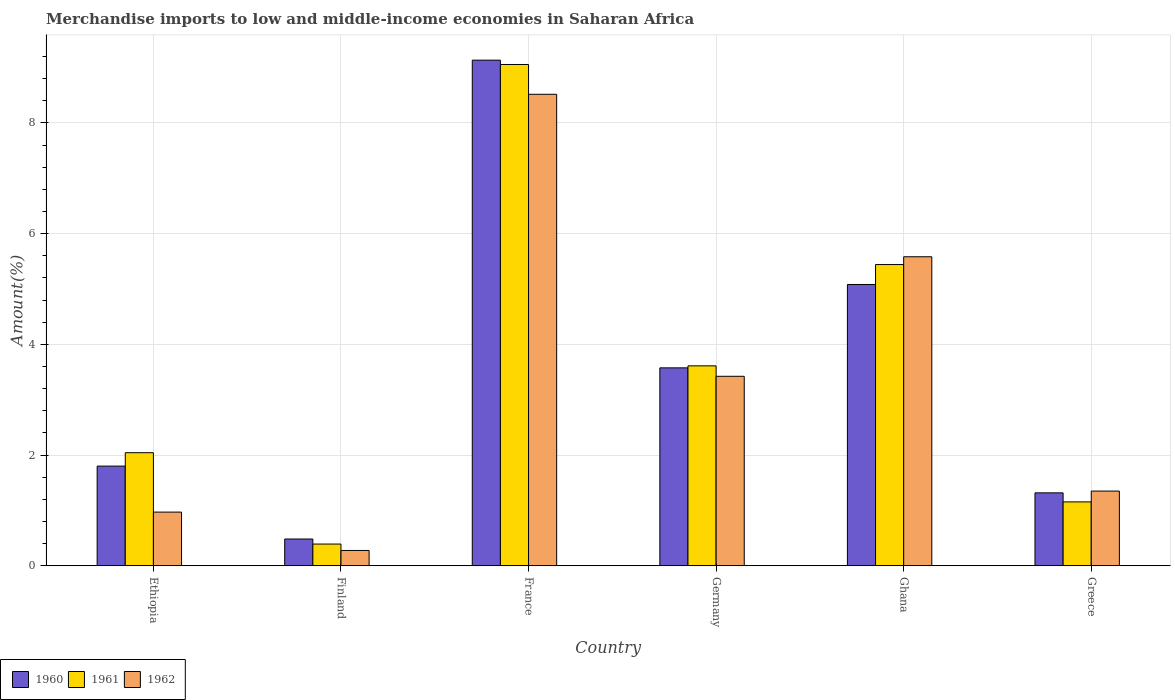How many groups of bars are there?
Make the answer very short. 6. How many bars are there on the 4th tick from the right?
Ensure brevity in your answer.  3. What is the label of the 6th group of bars from the left?
Your answer should be very brief. Greece. In how many cases, is the number of bars for a given country not equal to the number of legend labels?
Offer a very short reply. 0. What is the percentage of amount earned from merchandise imports in 1961 in Ghana?
Ensure brevity in your answer.  5.44. Across all countries, what is the maximum percentage of amount earned from merchandise imports in 1960?
Make the answer very short. 9.13. Across all countries, what is the minimum percentage of amount earned from merchandise imports in 1962?
Make the answer very short. 0.28. In which country was the percentage of amount earned from merchandise imports in 1962 maximum?
Give a very brief answer. France. In which country was the percentage of amount earned from merchandise imports in 1960 minimum?
Offer a terse response. Finland. What is the total percentage of amount earned from merchandise imports in 1962 in the graph?
Offer a terse response. 20.12. What is the difference between the percentage of amount earned from merchandise imports in 1962 in Finland and that in France?
Ensure brevity in your answer.  -8.24. What is the difference between the percentage of amount earned from merchandise imports in 1962 in Ethiopia and the percentage of amount earned from merchandise imports in 1961 in Germany?
Provide a short and direct response. -2.64. What is the average percentage of amount earned from merchandise imports in 1962 per country?
Offer a very short reply. 3.35. What is the difference between the percentage of amount earned from merchandise imports of/in 1961 and percentage of amount earned from merchandise imports of/in 1962 in Ethiopia?
Give a very brief answer. 1.07. In how many countries, is the percentage of amount earned from merchandise imports in 1962 greater than 4 %?
Give a very brief answer. 2. What is the ratio of the percentage of amount earned from merchandise imports in 1962 in Finland to that in Germany?
Your answer should be very brief. 0.08. What is the difference between the highest and the second highest percentage of amount earned from merchandise imports in 1960?
Your answer should be compact. 5.56. What is the difference between the highest and the lowest percentage of amount earned from merchandise imports in 1960?
Keep it short and to the point. 8.65. In how many countries, is the percentage of amount earned from merchandise imports in 1960 greater than the average percentage of amount earned from merchandise imports in 1960 taken over all countries?
Provide a succinct answer. 3. Are all the bars in the graph horizontal?
Your response must be concise. No. Where does the legend appear in the graph?
Your answer should be compact. Bottom left. What is the title of the graph?
Ensure brevity in your answer.  Merchandise imports to low and middle-income economies in Saharan Africa. Does "1988" appear as one of the legend labels in the graph?
Your response must be concise. No. What is the label or title of the X-axis?
Provide a succinct answer. Country. What is the label or title of the Y-axis?
Your answer should be very brief. Amount(%). What is the Amount(%) in 1960 in Ethiopia?
Make the answer very short. 1.8. What is the Amount(%) of 1961 in Ethiopia?
Your answer should be compact. 2.04. What is the Amount(%) of 1962 in Ethiopia?
Your response must be concise. 0.97. What is the Amount(%) of 1960 in Finland?
Your answer should be very brief. 0.48. What is the Amount(%) of 1961 in Finland?
Your answer should be compact. 0.39. What is the Amount(%) in 1962 in Finland?
Offer a terse response. 0.28. What is the Amount(%) of 1960 in France?
Provide a short and direct response. 9.13. What is the Amount(%) of 1961 in France?
Your answer should be very brief. 9.06. What is the Amount(%) in 1962 in France?
Provide a short and direct response. 8.52. What is the Amount(%) in 1960 in Germany?
Keep it short and to the point. 3.58. What is the Amount(%) of 1961 in Germany?
Offer a very short reply. 3.61. What is the Amount(%) in 1962 in Germany?
Give a very brief answer. 3.42. What is the Amount(%) in 1960 in Ghana?
Provide a succinct answer. 5.08. What is the Amount(%) in 1961 in Ghana?
Ensure brevity in your answer.  5.44. What is the Amount(%) in 1962 in Ghana?
Ensure brevity in your answer.  5.58. What is the Amount(%) in 1960 in Greece?
Your response must be concise. 1.32. What is the Amount(%) of 1961 in Greece?
Provide a succinct answer. 1.15. What is the Amount(%) of 1962 in Greece?
Give a very brief answer. 1.35. Across all countries, what is the maximum Amount(%) of 1960?
Provide a short and direct response. 9.13. Across all countries, what is the maximum Amount(%) in 1961?
Provide a short and direct response. 9.06. Across all countries, what is the maximum Amount(%) of 1962?
Your answer should be compact. 8.52. Across all countries, what is the minimum Amount(%) in 1960?
Your answer should be very brief. 0.48. Across all countries, what is the minimum Amount(%) of 1961?
Your answer should be compact. 0.39. Across all countries, what is the minimum Amount(%) in 1962?
Ensure brevity in your answer.  0.28. What is the total Amount(%) in 1960 in the graph?
Provide a succinct answer. 21.39. What is the total Amount(%) in 1961 in the graph?
Provide a short and direct response. 21.7. What is the total Amount(%) of 1962 in the graph?
Your response must be concise. 20.12. What is the difference between the Amount(%) in 1960 in Ethiopia and that in Finland?
Offer a terse response. 1.32. What is the difference between the Amount(%) in 1961 in Ethiopia and that in Finland?
Offer a very short reply. 1.65. What is the difference between the Amount(%) in 1962 in Ethiopia and that in Finland?
Your answer should be very brief. 0.69. What is the difference between the Amount(%) of 1960 in Ethiopia and that in France?
Ensure brevity in your answer.  -7.33. What is the difference between the Amount(%) of 1961 in Ethiopia and that in France?
Make the answer very short. -7.01. What is the difference between the Amount(%) in 1962 in Ethiopia and that in France?
Give a very brief answer. -7.55. What is the difference between the Amount(%) of 1960 in Ethiopia and that in Germany?
Your answer should be very brief. -1.77. What is the difference between the Amount(%) in 1961 in Ethiopia and that in Germany?
Give a very brief answer. -1.57. What is the difference between the Amount(%) in 1962 in Ethiopia and that in Germany?
Your response must be concise. -2.45. What is the difference between the Amount(%) of 1960 in Ethiopia and that in Ghana?
Give a very brief answer. -3.28. What is the difference between the Amount(%) of 1961 in Ethiopia and that in Ghana?
Your response must be concise. -3.4. What is the difference between the Amount(%) of 1962 in Ethiopia and that in Ghana?
Provide a succinct answer. -4.61. What is the difference between the Amount(%) in 1960 in Ethiopia and that in Greece?
Ensure brevity in your answer.  0.48. What is the difference between the Amount(%) of 1962 in Ethiopia and that in Greece?
Provide a succinct answer. -0.38. What is the difference between the Amount(%) of 1960 in Finland and that in France?
Your answer should be very brief. -8.65. What is the difference between the Amount(%) in 1961 in Finland and that in France?
Provide a succinct answer. -8.66. What is the difference between the Amount(%) of 1962 in Finland and that in France?
Keep it short and to the point. -8.24. What is the difference between the Amount(%) of 1960 in Finland and that in Germany?
Your response must be concise. -3.09. What is the difference between the Amount(%) of 1961 in Finland and that in Germany?
Provide a short and direct response. -3.22. What is the difference between the Amount(%) in 1962 in Finland and that in Germany?
Offer a terse response. -3.15. What is the difference between the Amount(%) of 1960 in Finland and that in Ghana?
Ensure brevity in your answer.  -4.6. What is the difference between the Amount(%) of 1961 in Finland and that in Ghana?
Make the answer very short. -5.05. What is the difference between the Amount(%) in 1962 in Finland and that in Ghana?
Ensure brevity in your answer.  -5.31. What is the difference between the Amount(%) in 1960 in Finland and that in Greece?
Offer a terse response. -0.83. What is the difference between the Amount(%) in 1961 in Finland and that in Greece?
Provide a succinct answer. -0.76. What is the difference between the Amount(%) in 1962 in Finland and that in Greece?
Keep it short and to the point. -1.07. What is the difference between the Amount(%) in 1960 in France and that in Germany?
Provide a succinct answer. 5.56. What is the difference between the Amount(%) of 1961 in France and that in Germany?
Your answer should be very brief. 5.44. What is the difference between the Amount(%) in 1962 in France and that in Germany?
Your answer should be very brief. 5.09. What is the difference between the Amount(%) of 1960 in France and that in Ghana?
Offer a very short reply. 4.05. What is the difference between the Amount(%) in 1961 in France and that in Ghana?
Make the answer very short. 3.61. What is the difference between the Amount(%) of 1962 in France and that in Ghana?
Make the answer very short. 2.93. What is the difference between the Amount(%) of 1960 in France and that in Greece?
Make the answer very short. 7.82. What is the difference between the Amount(%) in 1961 in France and that in Greece?
Provide a short and direct response. 7.9. What is the difference between the Amount(%) in 1962 in France and that in Greece?
Your answer should be very brief. 7.17. What is the difference between the Amount(%) in 1960 in Germany and that in Ghana?
Ensure brevity in your answer.  -1.51. What is the difference between the Amount(%) of 1961 in Germany and that in Ghana?
Your response must be concise. -1.83. What is the difference between the Amount(%) of 1962 in Germany and that in Ghana?
Provide a short and direct response. -2.16. What is the difference between the Amount(%) of 1960 in Germany and that in Greece?
Your answer should be very brief. 2.26. What is the difference between the Amount(%) of 1961 in Germany and that in Greece?
Your response must be concise. 2.46. What is the difference between the Amount(%) of 1962 in Germany and that in Greece?
Your answer should be very brief. 2.07. What is the difference between the Amount(%) in 1960 in Ghana and that in Greece?
Your response must be concise. 3.76. What is the difference between the Amount(%) in 1961 in Ghana and that in Greece?
Give a very brief answer. 4.29. What is the difference between the Amount(%) in 1962 in Ghana and that in Greece?
Provide a short and direct response. 4.23. What is the difference between the Amount(%) of 1960 in Ethiopia and the Amount(%) of 1961 in Finland?
Provide a short and direct response. 1.41. What is the difference between the Amount(%) in 1960 in Ethiopia and the Amount(%) in 1962 in Finland?
Your answer should be compact. 1.52. What is the difference between the Amount(%) of 1961 in Ethiopia and the Amount(%) of 1962 in Finland?
Ensure brevity in your answer.  1.77. What is the difference between the Amount(%) of 1960 in Ethiopia and the Amount(%) of 1961 in France?
Your answer should be very brief. -7.25. What is the difference between the Amount(%) in 1960 in Ethiopia and the Amount(%) in 1962 in France?
Ensure brevity in your answer.  -6.72. What is the difference between the Amount(%) of 1961 in Ethiopia and the Amount(%) of 1962 in France?
Give a very brief answer. -6.47. What is the difference between the Amount(%) of 1960 in Ethiopia and the Amount(%) of 1961 in Germany?
Your response must be concise. -1.81. What is the difference between the Amount(%) in 1960 in Ethiopia and the Amount(%) in 1962 in Germany?
Make the answer very short. -1.62. What is the difference between the Amount(%) of 1961 in Ethiopia and the Amount(%) of 1962 in Germany?
Offer a terse response. -1.38. What is the difference between the Amount(%) in 1960 in Ethiopia and the Amount(%) in 1961 in Ghana?
Give a very brief answer. -3.64. What is the difference between the Amount(%) in 1960 in Ethiopia and the Amount(%) in 1962 in Ghana?
Offer a very short reply. -3.78. What is the difference between the Amount(%) in 1961 in Ethiopia and the Amount(%) in 1962 in Ghana?
Your answer should be compact. -3.54. What is the difference between the Amount(%) of 1960 in Ethiopia and the Amount(%) of 1961 in Greece?
Offer a very short reply. 0.65. What is the difference between the Amount(%) in 1960 in Ethiopia and the Amount(%) in 1962 in Greece?
Keep it short and to the point. 0.45. What is the difference between the Amount(%) in 1961 in Ethiopia and the Amount(%) in 1962 in Greece?
Your answer should be very brief. 0.69. What is the difference between the Amount(%) in 1960 in Finland and the Amount(%) in 1961 in France?
Your answer should be very brief. -8.57. What is the difference between the Amount(%) in 1960 in Finland and the Amount(%) in 1962 in France?
Keep it short and to the point. -8.03. What is the difference between the Amount(%) in 1961 in Finland and the Amount(%) in 1962 in France?
Make the answer very short. -8.12. What is the difference between the Amount(%) of 1960 in Finland and the Amount(%) of 1961 in Germany?
Your answer should be very brief. -3.13. What is the difference between the Amount(%) of 1960 in Finland and the Amount(%) of 1962 in Germany?
Give a very brief answer. -2.94. What is the difference between the Amount(%) of 1961 in Finland and the Amount(%) of 1962 in Germany?
Make the answer very short. -3.03. What is the difference between the Amount(%) in 1960 in Finland and the Amount(%) in 1961 in Ghana?
Make the answer very short. -4.96. What is the difference between the Amount(%) of 1960 in Finland and the Amount(%) of 1962 in Ghana?
Your answer should be compact. -5.1. What is the difference between the Amount(%) of 1961 in Finland and the Amount(%) of 1962 in Ghana?
Offer a terse response. -5.19. What is the difference between the Amount(%) of 1960 in Finland and the Amount(%) of 1961 in Greece?
Ensure brevity in your answer.  -0.67. What is the difference between the Amount(%) in 1960 in Finland and the Amount(%) in 1962 in Greece?
Make the answer very short. -0.87. What is the difference between the Amount(%) in 1961 in Finland and the Amount(%) in 1962 in Greece?
Your response must be concise. -0.96. What is the difference between the Amount(%) in 1960 in France and the Amount(%) in 1961 in Germany?
Make the answer very short. 5.52. What is the difference between the Amount(%) in 1960 in France and the Amount(%) in 1962 in Germany?
Provide a succinct answer. 5.71. What is the difference between the Amount(%) in 1961 in France and the Amount(%) in 1962 in Germany?
Give a very brief answer. 5.63. What is the difference between the Amount(%) of 1960 in France and the Amount(%) of 1961 in Ghana?
Make the answer very short. 3.69. What is the difference between the Amount(%) of 1960 in France and the Amount(%) of 1962 in Ghana?
Keep it short and to the point. 3.55. What is the difference between the Amount(%) of 1961 in France and the Amount(%) of 1962 in Ghana?
Give a very brief answer. 3.47. What is the difference between the Amount(%) in 1960 in France and the Amount(%) in 1961 in Greece?
Make the answer very short. 7.98. What is the difference between the Amount(%) in 1960 in France and the Amount(%) in 1962 in Greece?
Provide a succinct answer. 7.78. What is the difference between the Amount(%) of 1961 in France and the Amount(%) of 1962 in Greece?
Keep it short and to the point. 7.71. What is the difference between the Amount(%) in 1960 in Germany and the Amount(%) in 1961 in Ghana?
Offer a terse response. -1.87. What is the difference between the Amount(%) of 1960 in Germany and the Amount(%) of 1962 in Ghana?
Your answer should be very brief. -2.01. What is the difference between the Amount(%) of 1961 in Germany and the Amount(%) of 1962 in Ghana?
Your answer should be very brief. -1.97. What is the difference between the Amount(%) of 1960 in Germany and the Amount(%) of 1961 in Greece?
Offer a terse response. 2.42. What is the difference between the Amount(%) of 1960 in Germany and the Amount(%) of 1962 in Greece?
Keep it short and to the point. 2.23. What is the difference between the Amount(%) in 1961 in Germany and the Amount(%) in 1962 in Greece?
Make the answer very short. 2.26. What is the difference between the Amount(%) of 1960 in Ghana and the Amount(%) of 1961 in Greece?
Your answer should be compact. 3.93. What is the difference between the Amount(%) in 1960 in Ghana and the Amount(%) in 1962 in Greece?
Your answer should be very brief. 3.73. What is the difference between the Amount(%) of 1961 in Ghana and the Amount(%) of 1962 in Greece?
Offer a very short reply. 4.09. What is the average Amount(%) of 1960 per country?
Your answer should be very brief. 3.57. What is the average Amount(%) of 1961 per country?
Offer a terse response. 3.62. What is the average Amount(%) in 1962 per country?
Ensure brevity in your answer.  3.35. What is the difference between the Amount(%) of 1960 and Amount(%) of 1961 in Ethiopia?
Offer a very short reply. -0.24. What is the difference between the Amount(%) in 1960 and Amount(%) in 1962 in Ethiopia?
Your answer should be very brief. 0.83. What is the difference between the Amount(%) of 1961 and Amount(%) of 1962 in Ethiopia?
Make the answer very short. 1.07. What is the difference between the Amount(%) of 1960 and Amount(%) of 1961 in Finland?
Keep it short and to the point. 0.09. What is the difference between the Amount(%) in 1960 and Amount(%) in 1962 in Finland?
Provide a short and direct response. 0.21. What is the difference between the Amount(%) in 1961 and Amount(%) in 1962 in Finland?
Make the answer very short. 0.12. What is the difference between the Amount(%) of 1960 and Amount(%) of 1961 in France?
Your answer should be compact. 0.08. What is the difference between the Amount(%) of 1960 and Amount(%) of 1962 in France?
Offer a very short reply. 0.62. What is the difference between the Amount(%) in 1961 and Amount(%) in 1962 in France?
Keep it short and to the point. 0.54. What is the difference between the Amount(%) in 1960 and Amount(%) in 1961 in Germany?
Give a very brief answer. -0.04. What is the difference between the Amount(%) of 1960 and Amount(%) of 1962 in Germany?
Give a very brief answer. 0.15. What is the difference between the Amount(%) of 1961 and Amount(%) of 1962 in Germany?
Ensure brevity in your answer.  0.19. What is the difference between the Amount(%) of 1960 and Amount(%) of 1961 in Ghana?
Your response must be concise. -0.36. What is the difference between the Amount(%) in 1960 and Amount(%) in 1962 in Ghana?
Your answer should be compact. -0.5. What is the difference between the Amount(%) of 1961 and Amount(%) of 1962 in Ghana?
Offer a very short reply. -0.14. What is the difference between the Amount(%) in 1960 and Amount(%) in 1961 in Greece?
Provide a short and direct response. 0.16. What is the difference between the Amount(%) of 1960 and Amount(%) of 1962 in Greece?
Your answer should be compact. -0.03. What is the difference between the Amount(%) of 1961 and Amount(%) of 1962 in Greece?
Your answer should be compact. -0.2. What is the ratio of the Amount(%) of 1960 in Ethiopia to that in Finland?
Ensure brevity in your answer.  3.72. What is the ratio of the Amount(%) in 1961 in Ethiopia to that in Finland?
Offer a terse response. 5.2. What is the ratio of the Amount(%) in 1962 in Ethiopia to that in Finland?
Keep it short and to the point. 3.5. What is the ratio of the Amount(%) in 1960 in Ethiopia to that in France?
Your response must be concise. 0.2. What is the ratio of the Amount(%) in 1961 in Ethiopia to that in France?
Keep it short and to the point. 0.23. What is the ratio of the Amount(%) in 1962 in Ethiopia to that in France?
Make the answer very short. 0.11. What is the ratio of the Amount(%) of 1960 in Ethiopia to that in Germany?
Give a very brief answer. 0.5. What is the ratio of the Amount(%) in 1961 in Ethiopia to that in Germany?
Provide a succinct answer. 0.57. What is the ratio of the Amount(%) of 1962 in Ethiopia to that in Germany?
Ensure brevity in your answer.  0.28. What is the ratio of the Amount(%) of 1960 in Ethiopia to that in Ghana?
Your answer should be compact. 0.35. What is the ratio of the Amount(%) of 1961 in Ethiopia to that in Ghana?
Provide a short and direct response. 0.38. What is the ratio of the Amount(%) in 1962 in Ethiopia to that in Ghana?
Ensure brevity in your answer.  0.17. What is the ratio of the Amount(%) of 1960 in Ethiopia to that in Greece?
Ensure brevity in your answer.  1.37. What is the ratio of the Amount(%) of 1961 in Ethiopia to that in Greece?
Your answer should be compact. 1.77. What is the ratio of the Amount(%) in 1962 in Ethiopia to that in Greece?
Provide a short and direct response. 0.72. What is the ratio of the Amount(%) of 1960 in Finland to that in France?
Offer a terse response. 0.05. What is the ratio of the Amount(%) of 1961 in Finland to that in France?
Your answer should be compact. 0.04. What is the ratio of the Amount(%) of 1962 in Finland to that in France?
Your answer should be compact. 0.03. What is the ratio of the Amount(%) of 1960 in Finland to that in Germany?
Give a very brief answer. 0.14. What is the ratio of the Amount(%) in 1961 in Finland to that in Germany?
Your response must be concise. 0.11. What is the ratio of the Amount(%) of 1962 in Finland to that in Germany?
Your answer should be very brief. 0.08. What is the ratio of the Amount(%) in 1960 in Finland to that in Ghana?
Your answer should be very brief. 0.1. What is the ratio of the Amount(%) of 1961 in Finland to that in Ghana?
Offer a terse response. 0.07. What is the ratio of the Amount(%) of 1962 in Finland to that in Ghana?
Provide a short and direct response. 0.05. What is the ratio of the Amount(%) in 1960 in Finland to that in Greece?
Ensure brevity in your answer.  0.37. What is the ratio of the Amount(%) in 1961 in Finland to that in Greece?
Provide a succinct answer. 0.34. What is the ratio of the Amount(%) of 1962 in Finland to that in Greece?
Give a very brief answer. 0.21. What is the ratio of the Amount(%) in 1960 in France to that in Germany?
Provide a succinct answer. 2.55. What is the ratio of the Amount(%) of 1961 in France to that in Germany?
Give a very brief answer. 2.51. What is the ratio of the Amount(%) of 1962 in France to that in Germany?
Offer a very short reply. 2.49. What is the ratio of the Amount(%) of 1960 in France to that in Ghana?
Make the answer very short. 1.8. What is the ratio of the Amount(%) of 1961 in France to that in Ghana?
Your response must be concise. 1.66. What is the ratio of the Amount(%) in 1962 in France to that in Ghana?
Your answer should be very brief. 1.53. What is the ratio of the Amount(%) of 1960 in France to that in Greece?
Your answer should be compact. 6.93. What is the ratio of the Amount(%) in 1961 in France to that in Greece?
Provide a short and direct response. 7.85. What is the ratio of the Amount(%) of 1962 in France to that in Greece?
Give a very brief answer. 6.31. What is the ratio of the Amount(%) of 1960 in Germany to that in Ghana?
Provide a short and direct response. 0.7. What is the ratio of the Amount(%) of 1961 in Germany to that in Ghana?
Provide a short and direct response. 0.66. What is the ratio of the Amount(%) in 1962 in Germany to that in Ghana?
Give a very brief answer. 0.61. What is the ratio of the Amount(%) in 1960 in Germany to that in Greece?
Your answer should be compact. 2.71. What is the ratio of the Amount(%) of 1961 in Germany to that in Greece?
Offer a terse response. 3.13. What is the ratio of the Amount(%) in 1962 in Germany to that in Greece?
Your response must be concise. 2.54. What is the ratio of the Amount(%) of 1960 in Ghana to that in Greece?
Ensure brevity in your answer.  3.86. What is the ratio of the Amount(%) in 1961 in Ghana to that in Greece?
Keep it short and to the point. 4.71. What is the ratio of the Amount(%) of 1962 in Ghana to that in Greece?
Keep it short and to the point. 4.14. What is the difference between the highest and the second highest Amount(%) of 1960?
Keep it short and to the point. 4.05. What is the difference between the highest and the second highest Amount(%) of 1961?
Your answer should be compact. 3.61. What is the difference between the highest and the second highest Amount(%) in 1962?
Your answer should be very brief. 2.93. What is the difference between the highest and the lowest Amount(%) of 1960?
Make the answer very short. 8.65. What is the difference between the highest and the lowest Amount(%) of 1961?
Provide a short and direct response. 8.66. What is the difference between the highest and the lowest Amount(%) of 1962?
Provide a short and direct response. 8.24. 